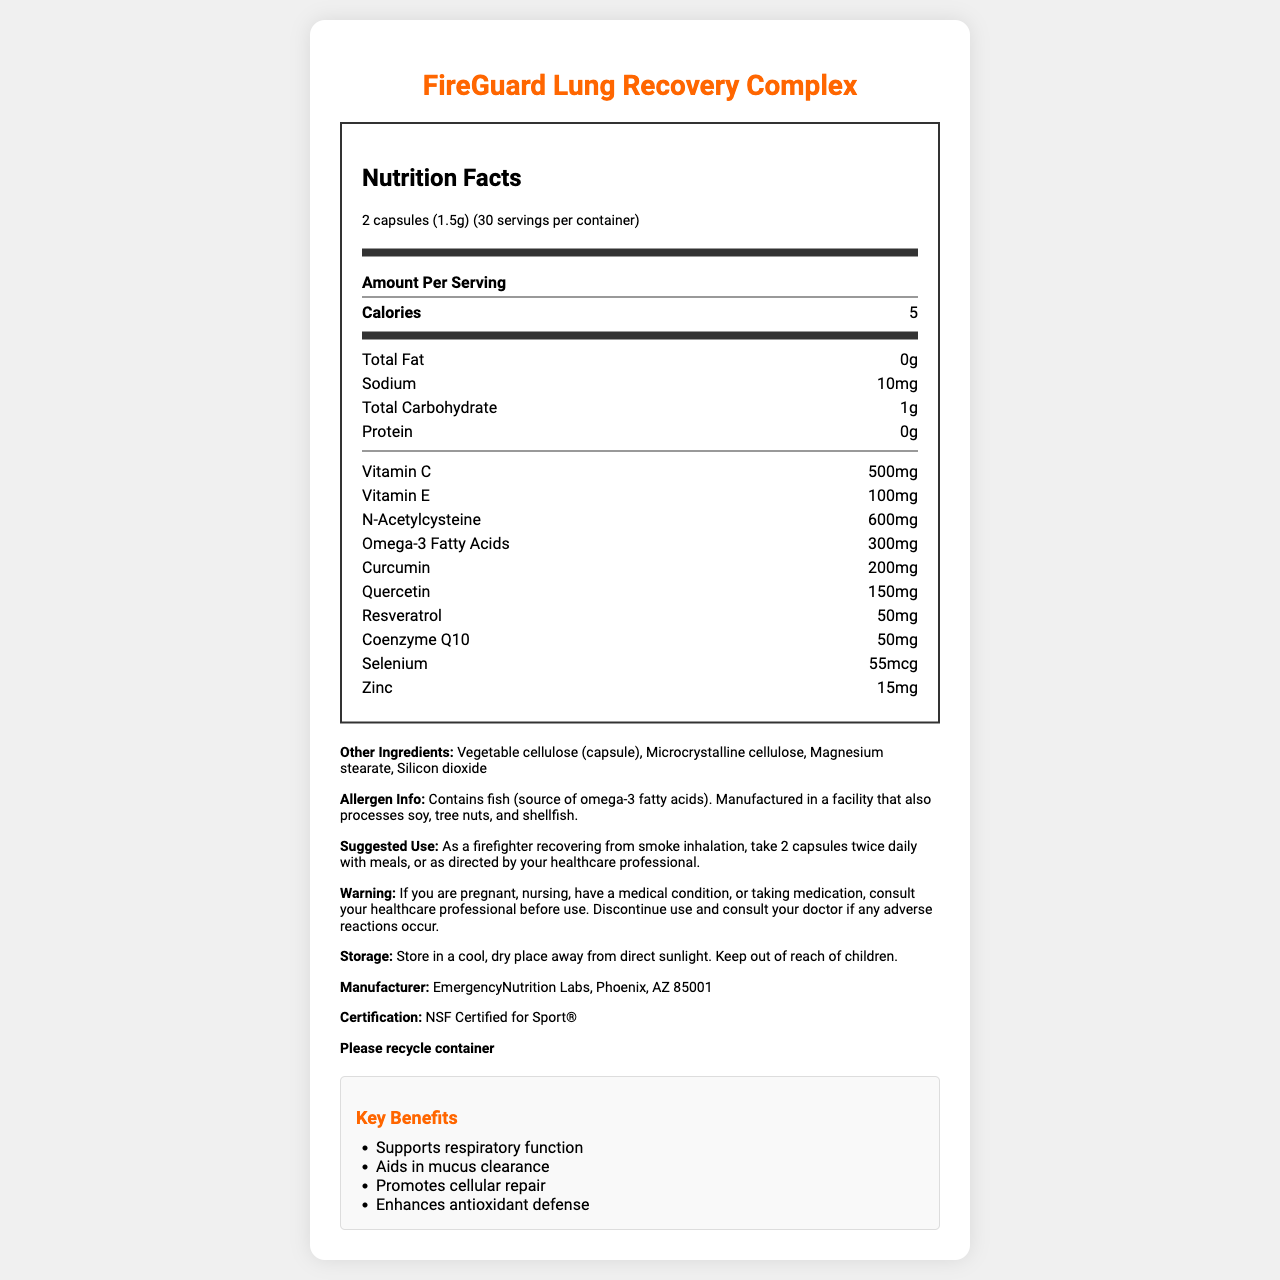what is the serving size of FireGuard Lung Recovery Complex? The serving size is clearly mentioned in the nutrition label as "2 capsules (1.5g)".
Answer: 2 capsules (1.5g) How many servings are there per container? The label states that there are 30 servings per container.
Answer: 30 How much Vitamin C is in one serving? The nutrition label indicates that one serving contains 500mg of Vitamin C.
Answer: 500mg How much sodium does each serving contain? The label shows that each serving contains 10mg of sodium.
Answer: 10mg What are the key benefits of this supplement? These key benefits are listed under the "Key Benefits" section of the document.
Answer: Supports respiratory function, Aids in mucus clearance, Promotes cellular repair, Enhances antioxidant defense Which ingredient is the source of omega-3 fatty acids? A. Fish B. Soy C. Tree nuts D. Shellfish The allergen information mentions that this product contains fish, which is the source of omega-3 fatty acids.
Answer: A. Fish What is the amount of zinc per serving? Zinc content per serving is listed as 15mg in the nutritional information part of the label.
Answer: 15mg What is the suggested use for this supplement? A. 1 capsule once daily B. 2 capsules twice daily with meals C. 3 capsules twice daily D. 1 capsule twice daily with meals The suggested use provided on the label is to take 2 capsules twice daily with meals.
Answer: B. 2 capsules twice daily with meals Is this product NSF Certified for Sport®? The certification noted on the label is "NSF Certified for Sport®".
Answer: Yes Does this product contain any protein? The label mentions that the product contains 0g of protein.
Answer: No Which ingredient aids in cellular repair and antioxidant defense? Coenzyme Q10 is known for its role in cellular repair and enhancing antioxidant defense, as can be inferred from the key benefits section.
Answer: Coenzyme Q10 What precautions should be taken if you are pregnant or nursing before using this supplement? The warning section advises pregnant or nursing individuals to consult their healthcare professional before use.
Answer: Consult your healthcare professional before use. List three active ingredients in this supplement other than vitamins. The label lists N-Acetylcysteine, Omega-3 fatty acids, and Curcumin as active ingredients.
Answer: N-Acetylcysteine, Omega-3 fatty acids, Curcumin What is the main idea of this document? The document thoroughly describes the FireGuard Lung Recovery Complex, including serving size, nutritional content, and specific ingredients helpful for lung recovery.
Answer: The document provides detailed nutritional information, suggested use, warnings, storage instructions, and key benefits of the FireGuard Lung Recovery Complex, a supplement aimed at supporting lung health and recovery from smoke inhalation. Can the source of omega-3 fatty acids cause allergic reactions? The allergen information states that the product contains fish, which can cause allergic reactions in some individuals.
Answer: Yes How many milligrams of resveratrol are in one serving? The nutrition label shows that each serving contains 50mg of resveratrol.
Answer: 50mg Are there tree nuts in this product? The allergen information says that this product is manufactured in a facility that processes tree nuts, but it does not confirm whether tree nuts are in this actual product.
Answer: Cannot be determined 